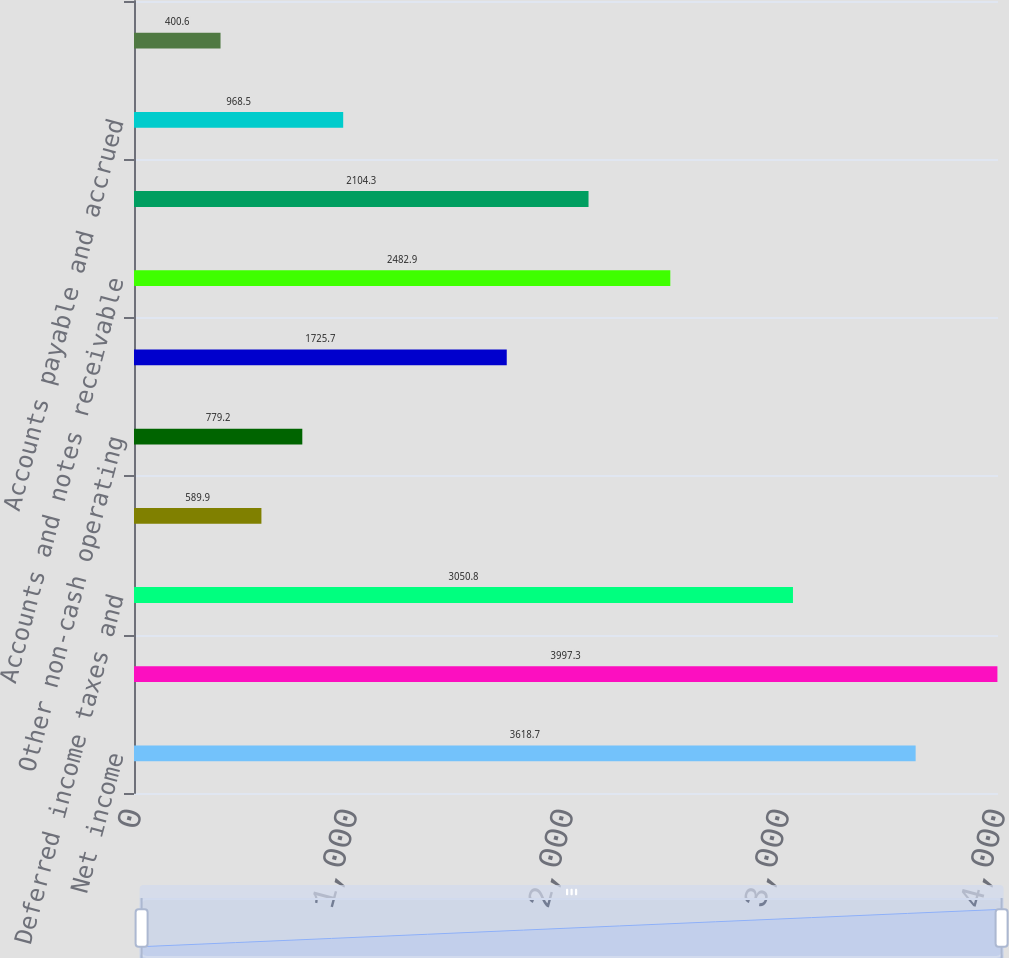Convert chart. <chart><loc_0><loc_0><loc_500><loc_500><bar_chart><fcel>Net income<fcel>Depreciation and amortization<fcel>Deferred income taxes and<fcel>Bad debt expense<fcel>Other non-cash operating<fcel>Postretirement benefits<fcel>Accounts and notes receivable<fcel>Inventories<fcel>Accounts payable and accrued<fcel>Other current and non-current<nl><fcel>3618.7<fcel>3997.3<fcel>3050.8<fcel>589.9<fcel>779.2<fcel>1725.7<fcel>2482.9<fcel>2104.3<fcel>968.5<fcel>400.6<nl></chart> 